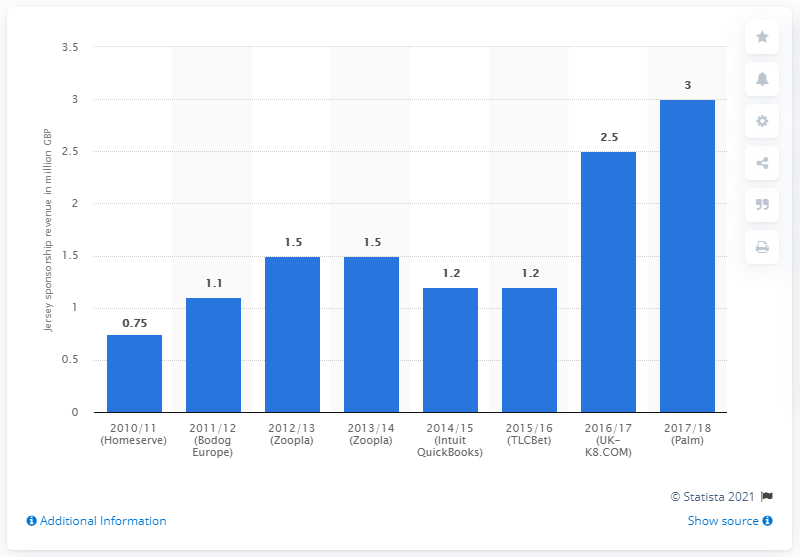Give some essential details in this illustration. In the 2017/18 season, West Bromwich Albion received a total of £3 million from its jersey sponsor, Palm. 